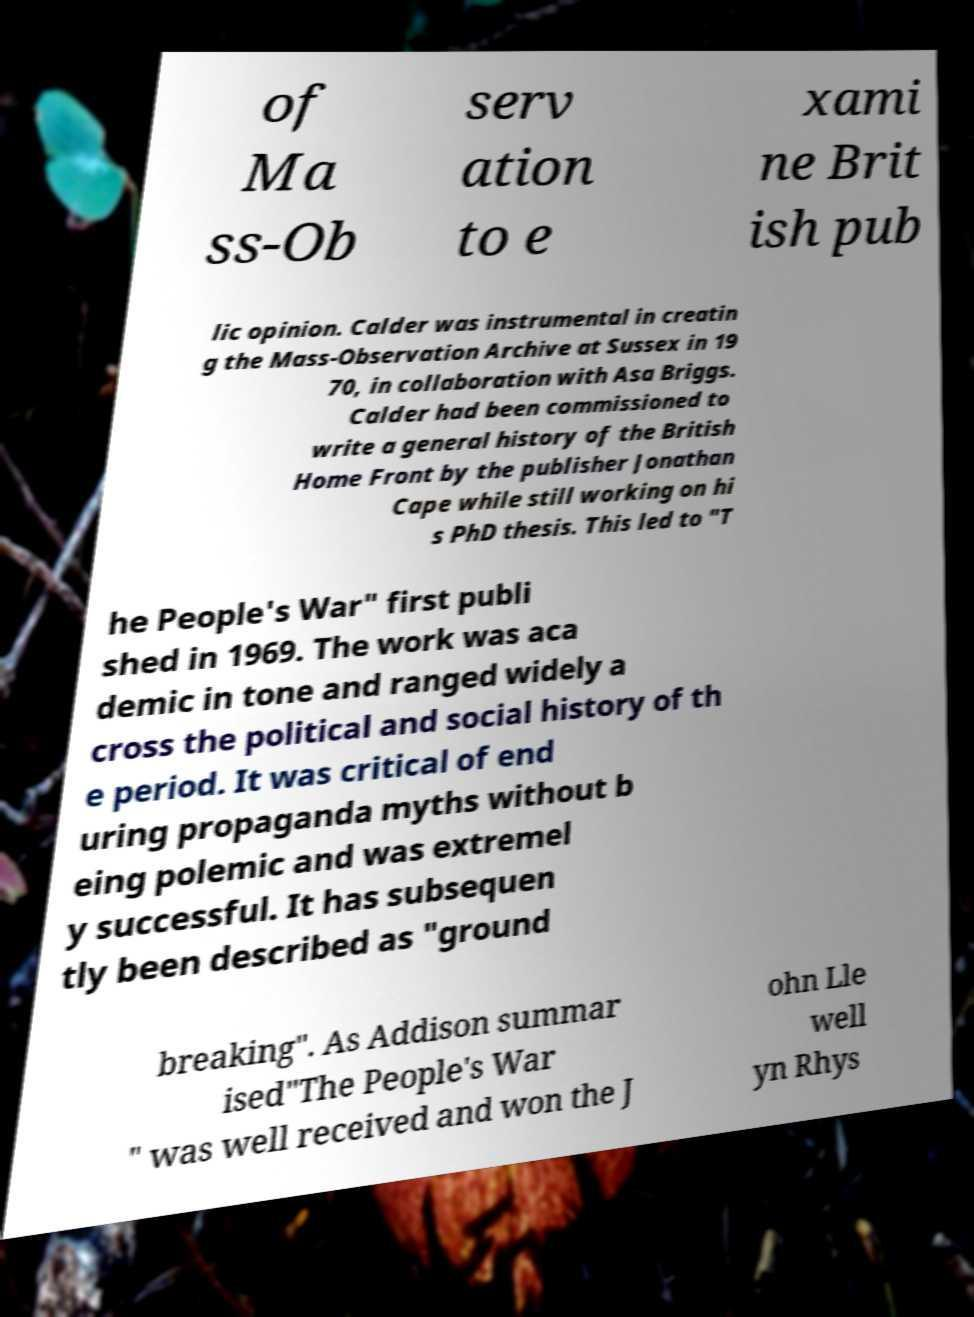Could you extract and type out the text from this image? of Ma ss-Ob serv ation to e xami ne Brit ish pub lic opinion. Calder was instrumental in creatin g the Mass-Observation Archive at Sussex in 19 70, in collaboration with Asa Briggs. Calder had been commissioned to write a general history of the British Home Front by the publisher Jonathan Cape while still working on hi s PhD thesis. This led to "T he People's War" first publi shed in 1969. The work was aca demic in tone and ranged widely a cross the political and social history of th e period. It was critical of end uring propaganda myths without b eing polemic and was extremel y successful. It has subsequen tly been described as "ground breaking". As Addison summar ised"The People's War " was well received and won the J ohn Lle well yn Rhys 